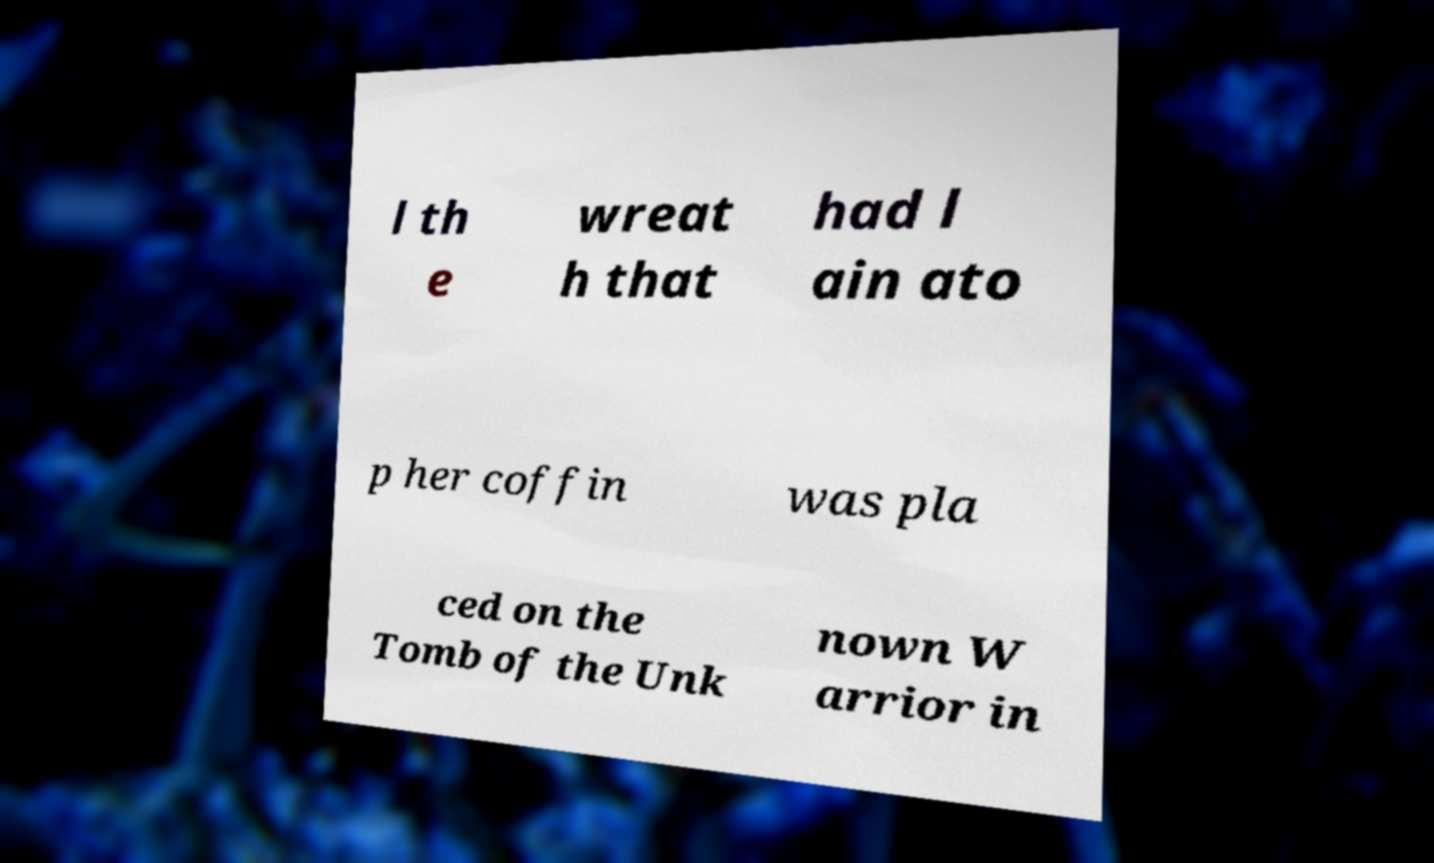Could you extract and type out the text from this image? l th e wreat h that had l ain ato p her coffin was pla ced on the Tomb of the Unk nown W arrior in 